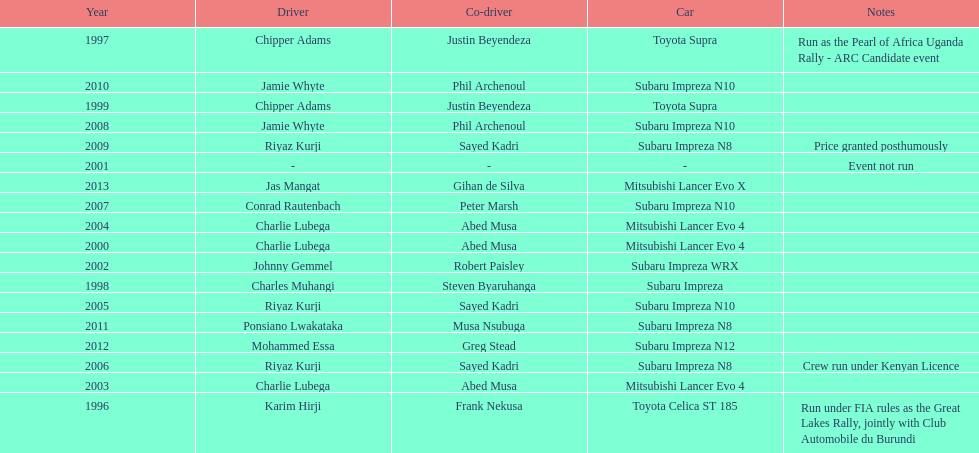Do chipper adams and justin beyendeza have more than 3 wins? No. 